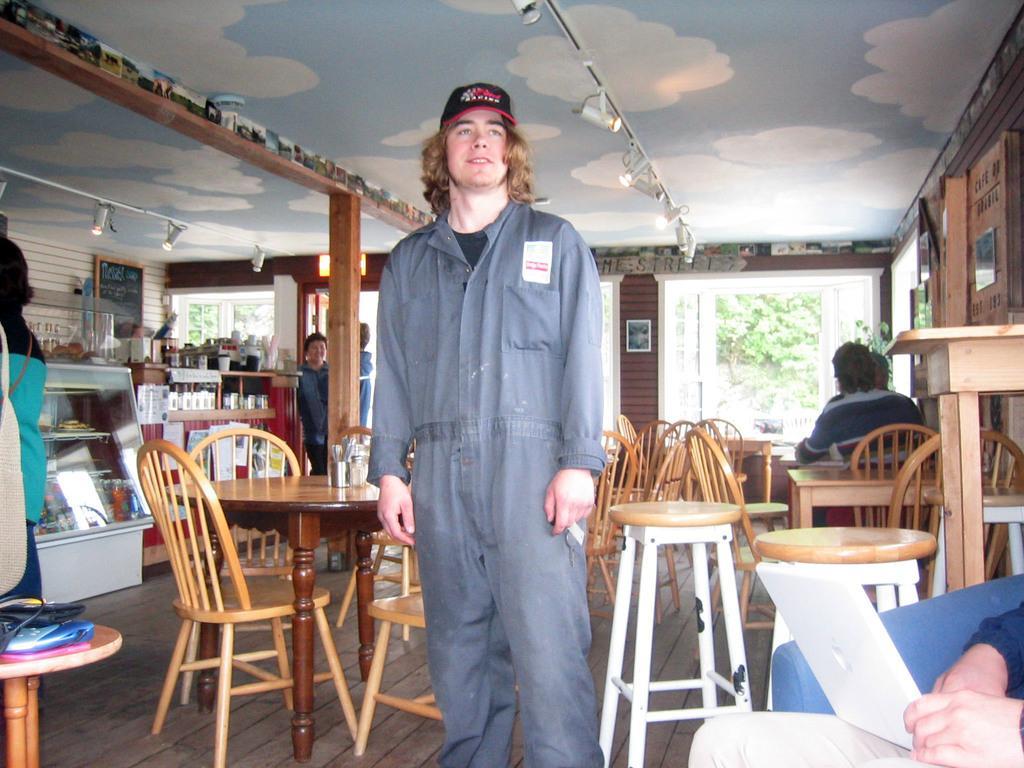Describe this image in one or two sentences. This image is taken inside a room. In the right side of the image a man is sitting in a sofa and holding a tab in his hand. In the middle of the image a man is standing on the floor. In the left side of the image there is a stool with few things on it. At the top of the image there is a roof. At the background there is a wall and picture frames on it and there were few trees outside the room 